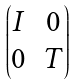<formula> <loc_0><loc_0><loc_500><loc_500>\begin{pmatrix} I & 0 \\ 0 & T \end{pmatrix}</formula> 